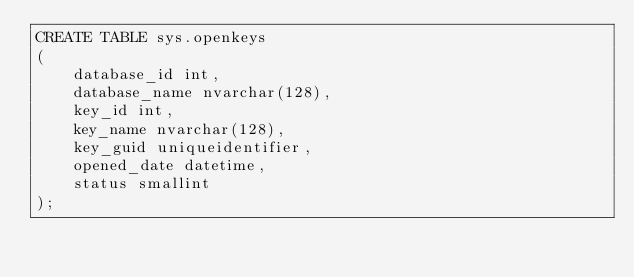Convert code to text. <code><loc_0><loc_0><loc_500><loc_500><_SQL_>CREATE TABLE sys.openkeys
(
    database_id int,
    database_name nvarchar(128),
    key_id int,
    key_name nvarchar(128),
    key_guid uniqueidentifier,
    opened_date datetime,
    status smallint
);</code> 